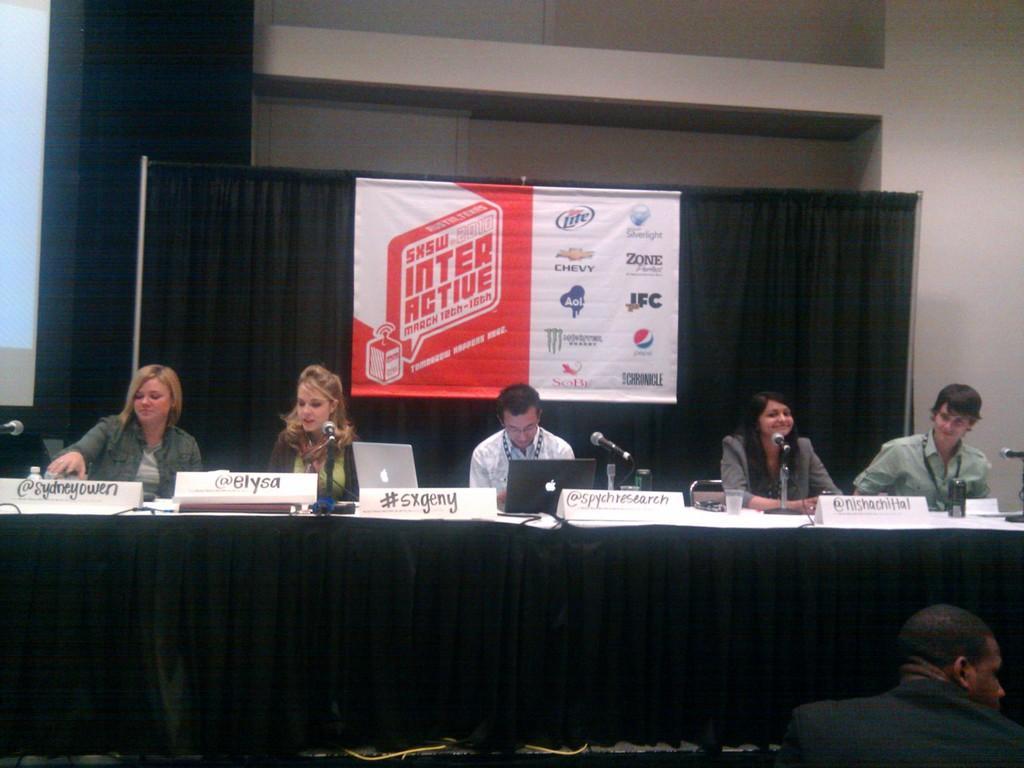Could you give a brief overview of what you see in this image? In this image I see 3 women and 2 men who are sitting and I see the tables on which there are laptops, mics and name boards and I see that these both are smiling and I see another man over here. In the background I see the black cloth on which there is a banner and there is something written on it and I see logos and I see the wall and I see the projector screen over here. 